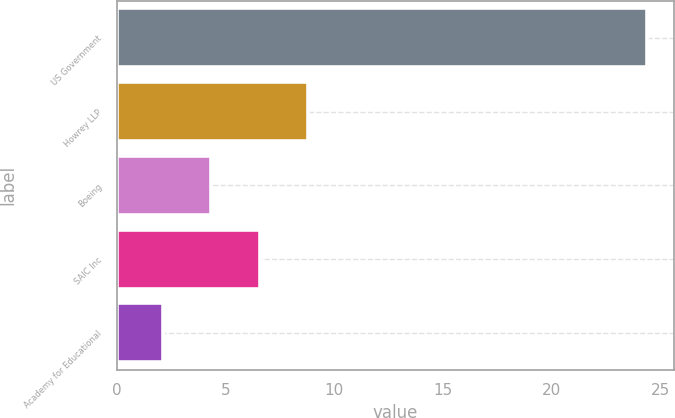<chart> <loc_0><loc_0><loc_500><loc_500><bar_chart><fcel>US Government<fcel>Howrey LLP<fcel>Boeing<fcel>SAIC Inc<fcel>Academy for Educational<nl><fcel>24.4<fcel>8.79<fcel>4.33<fcel>6.56<fcel>2.1<nl></chart> 